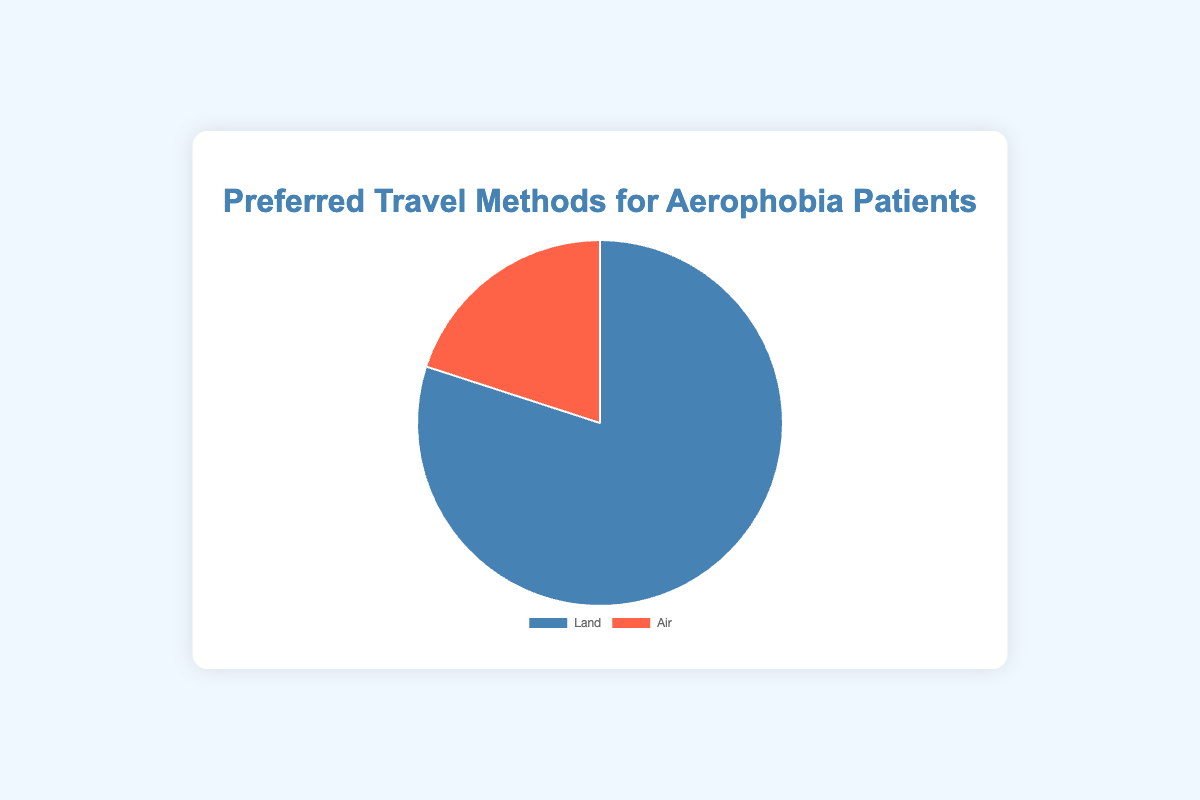Which travel method is preferred by the majority of aerophobia patients? The figure displays two segments of a pie chart, labeled "Land" and "Air." The "Land" segment accounts for 80%, while the "Air" segment accounts for 20%. Since 80% is greater than 20%, the majority of aerophobia patients prefer to travel by land.
Answer: Land What is the ratio of patients who prefer traveling by land to those who prefer traveling by air? The percentages given are 80% for land and 20% for air. To find the ratio, divide the percentage of land travelers by the percentage of air travelers: 80/20 = 4/1. Therefore, the ratio is 4:1.
Answer: 4:1 By how many percentage points is the preference for land travel greater than for air travel? The figure indicates that 80% of patients prefer land travel and 20% prefer air travel. Subtract the smaller percentage (air) from the larger percentage (land): 80% - 20% = 60%. Thus, land travel is preferred by 60 percentage points more.
Answer: 60% Which color represents the preferred travel method for fewer patients? The pie chart uses color to represent different travel methods. The segment representing "Air" travel is colored in red. Since only 20% of patients prefer air travel, the red color indicates the travel method preferred by fewer patients.
Answer: Red If the total number of aerophobia patients surveyed was 100, how many patients prefer traveling by land? Given that 80% of the patients prefer land travel, and the total number of patients is 100, multiply 100 by 80%: \( 100 \times 0.80 = 80 \). Therefore, 80 patients prefer to travel by land.
Answer: 80 If 100 more patients were added to the survey, maintaining the same preference proportions, how many in total would prefer air travel? Originally, 20% of the patients prefer air travel. Let’s assume the initial total number of patients is 100, thus 20 patients prefer air travel. If we add 100 more patients, the new total is 200. Since the preference proportion stays the same, 20% of 200 is \( 200 \times 0.20 = 40 \). Therefore, 40 patients would prefer air travel.
Answer: 40 Is the segment representing land travel larger than the segment representing air travel? Examine the pie chart's segment sizes. The segment for land travel makes up 80%, and the segment for air travel makes up 20%. Since 80% is larger than 20%, the segment for land travel is indeed larger.
Answer: Yes 